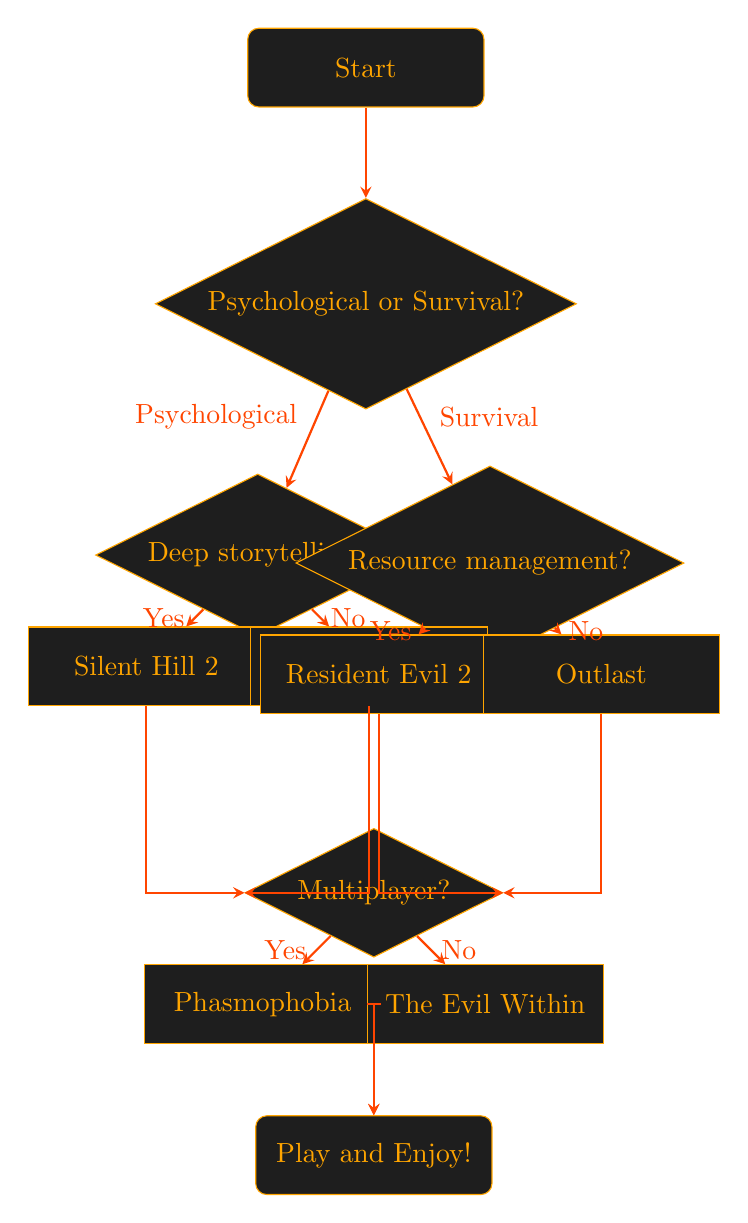What are the options under the genre question? The genre question has two options leading to different paths: 'Psychological' and 'Survival'. These options dictate the next steps in the flowchart based on the player's preference.
Answer: Psychological, Survival What game is recommended for those who prefer psychological horror and enjoy deep storytelling? If a player chooses 'Psychological' and then answers 'Yes' to enjoying deep storytelling, the flowchart leads to the recommendation of 'Silent Hill 2' as the game to play.
Answer: Silent Hill 2 What happens if a player selects 'Survival' and answers 'No' to wanting resource management? Selecting 'Survival' and then answering 'No' leads the player to the recommendation of 'Outlast', which does not involve resource management.
Answer: Outlast How many total games are recommended in the flowchart? The flowchart presents four different game recommendations: 'Silent Hill 2', 'Layers of Fear', 'Resident Evil 2', and 'Outlast', making for a total of four games.
Answer: 4 If a player loves multiplayer horror games, which game is recommended from the flowchart? For a player looking for a multiplayer experience, they would follow the path leading to the 'Multiplayer?' decision after any of the initial game recommendations. Answering 'Yes' leads to 'Phasmophobia' being recommended.
Answer: Phasmophobia Which game would be recommended for someone who prefers psychological horror but isn't interested in deep storytelling? A preference for psychological horror with a 'No' answer regarding deep storytelling leads to the recommendation of 'Layers of Fear', which emphasizes atmospheric horror without as much focus on character arcs.
Answer: Layers of Fear What is the outcome if the player prefers survival horror with resource management? By choosing 'Survival' and answering 'Yes' regarding resource management, the recommendation leads directly to 'Resident Evil 2', known for its resource management gameplay mechanics.
Answer: Resident Evil 2 What is the final node in the flowchart? The flowchart concludes with the 'Play and Enjoy!' node, symbolizing the closure of the decision-making process and the encouragement to engage in playing a selected game.
Answer: Play and Enjoy! 